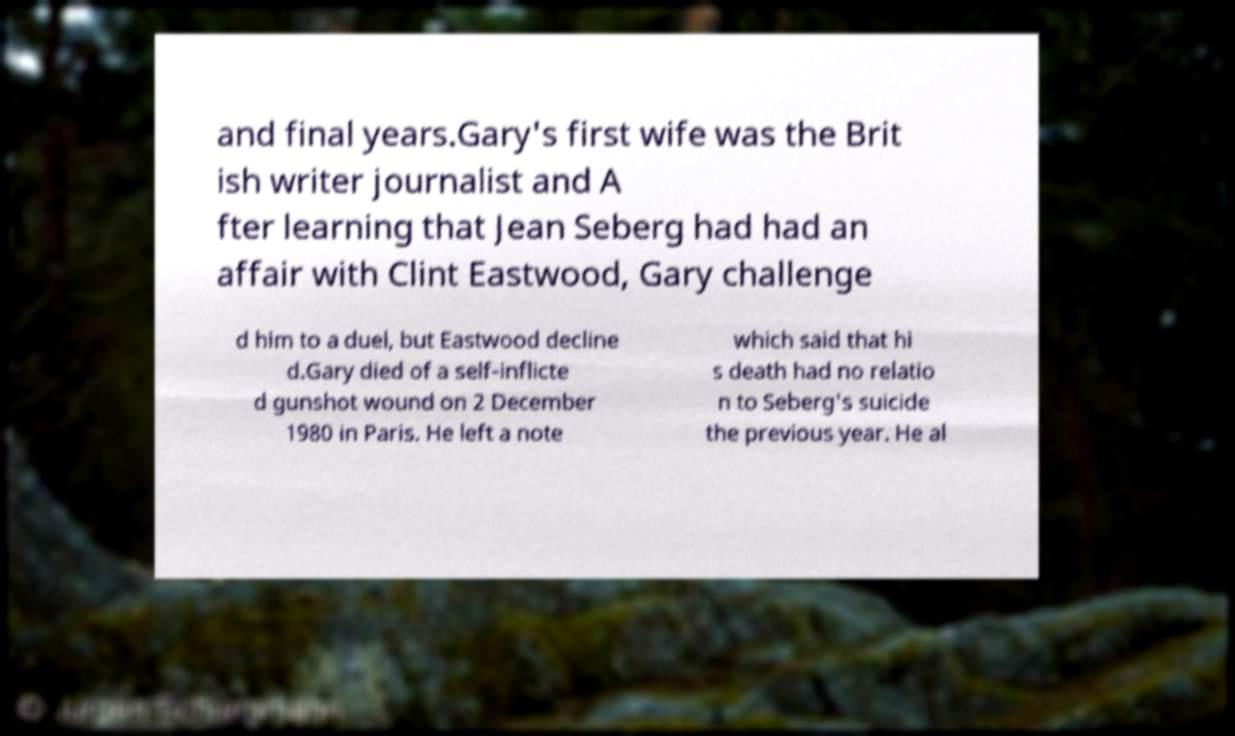Please identify and transcribe the text found in this image. and final years.Gary's first wife was the Brit ish writer journalist and A fter learning that Jean Seberg had had an affair with Clint Eastwood, Gary challenge d him to a duel, but Eastwood decline d.Gary died of a self-inflicte d gunshot wound on 2 December 1980 in Paris. He left a note which said that hi s death had no relatio n to Seberg's suicide the previous year. He al 